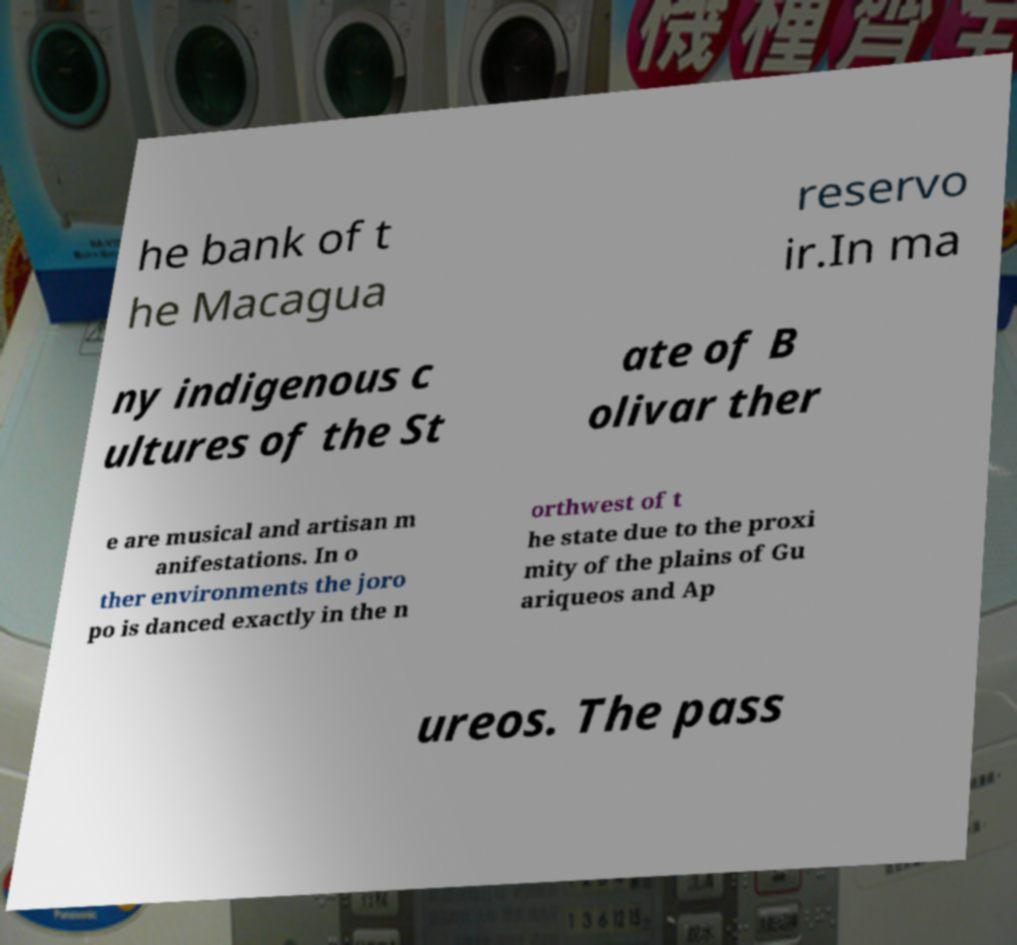Can you accurately transcribe the text from the provided image for me? he bank of t he Macagua reservo ir.In ma ny indigenous c ultures of the St ate of B olivar ther e are musical and artisan m anifestations. In o ther environments the joro po is danced exactly in the n orthwest of t he state due to the proxi mity of the plains of Gu ariqueos and Ap ureos. The pass 